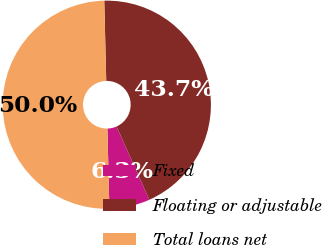<chart> <loc_0><loc_0><loc_500><loc_500><pie_chart><fcel>Fixed<fcel>Floating or adjustable<fcel>Total loans net<nl><fcel>6.31%<fcel>43.69%<fcel>50.0%<nl></chart> 